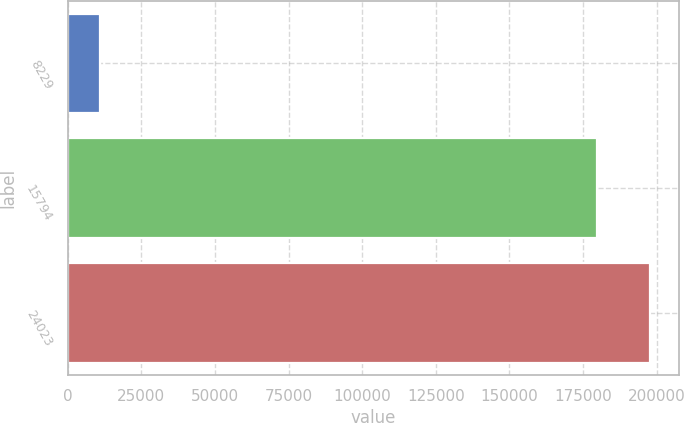<chart> <loc_0><loc_0><loc_500><loc_500><bar_chart><fcel>8229<fcel>15794<fcel>24023<nl><fcel>11021<fcel>179741<fcel>197715<nl></chart> 